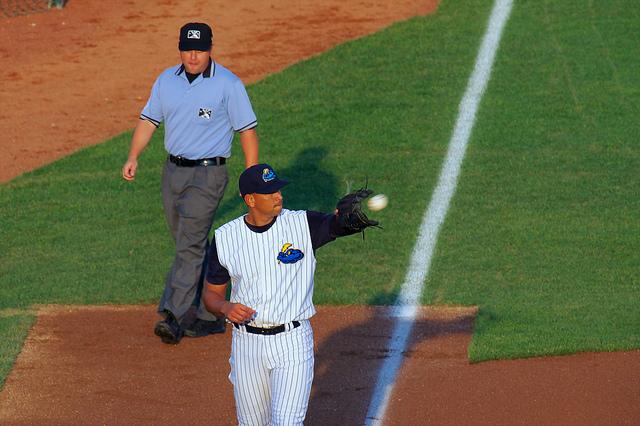Are the men playing a sport?
Answer briefly. Yes. Are the players stripes going vertically or horizontally?
Be succinct. Vertically. Who is wearing the blue collared shirt?
Give a very brief answer. Umpire. 